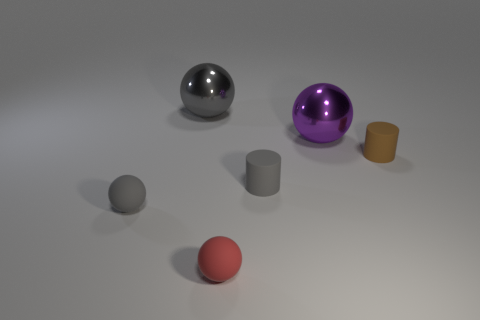Add 1 tiny gray matte spheres. How many objects exist? 7 Subtract all cylinders. How many objects are left? 4 Subtract all rubber cylinders. Subtract all big yellow cylinders. How many objects are left? 4 Add 3 small brown rubber objects. How many small brown rubber objects are left? 4 Add 3 large purple metal balls. How many large purple metal balls exist? 4 Subtract 0 green cylinders. How many objects are left? 6 